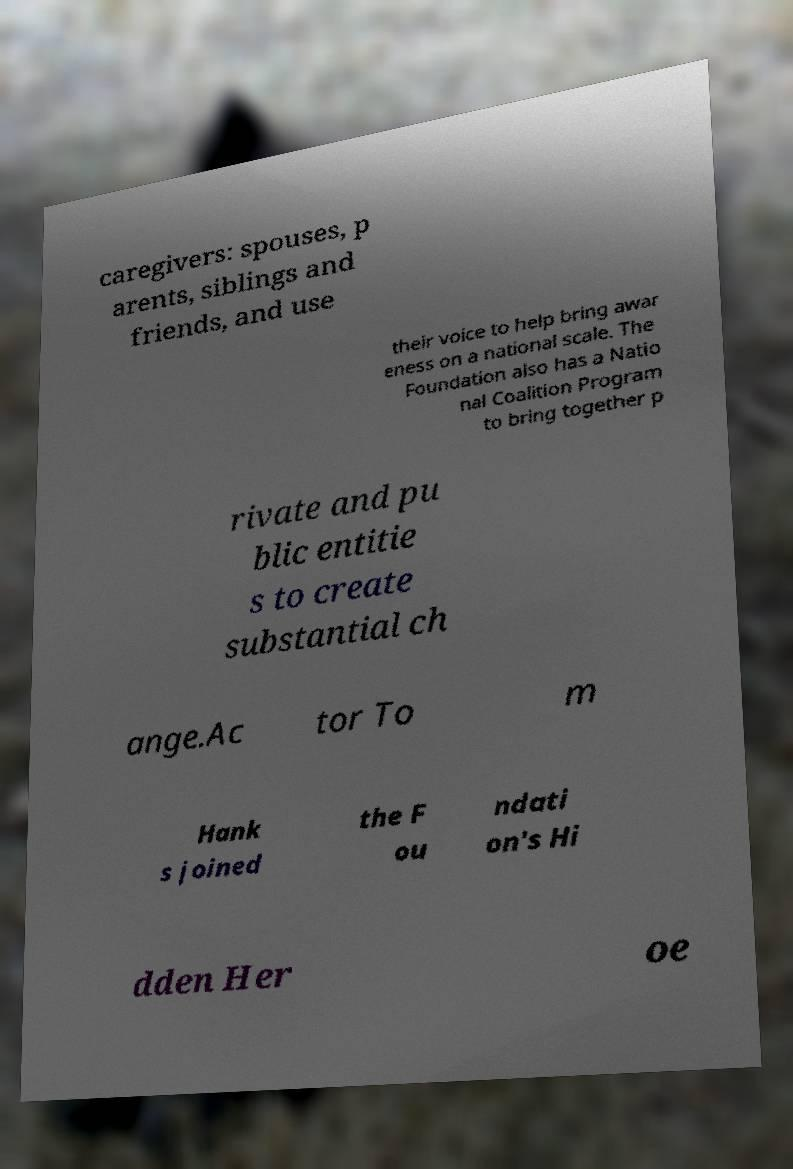Can you accurately transcribe the text from the provided image for me? caregivers: spouses, p arents, siblings and friends, and use their voice to help bring awar eness on a national scale. The Foundation also has a Natio nal Coalition Program to bring together p rivate and pu blic entitie s to create substantial ch ange.Ac tor To m Hank s joined the F ou ndati on's Hi dden Her oe 